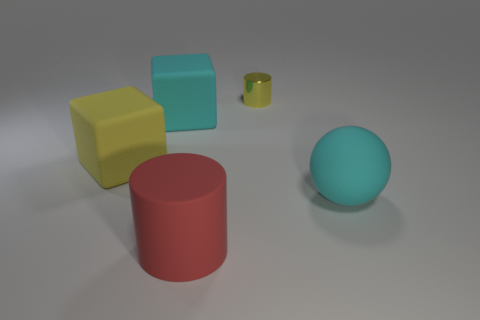Add 5 large yellow rubber blocks. How many objects exist? 10 Subtract all blocks. How many objects are left? 3 Subtract 0 blue cubes. How many objects are left? 5 Subtract all blue rubber spheres. Subtract all big yellow blocks. How many objects are left? 4 Add 3 small yellow metallic cylinders. How many small yellow metallic cylinders are left? 4 Add 3 matte blocks. How many matte blocks exist? 5 